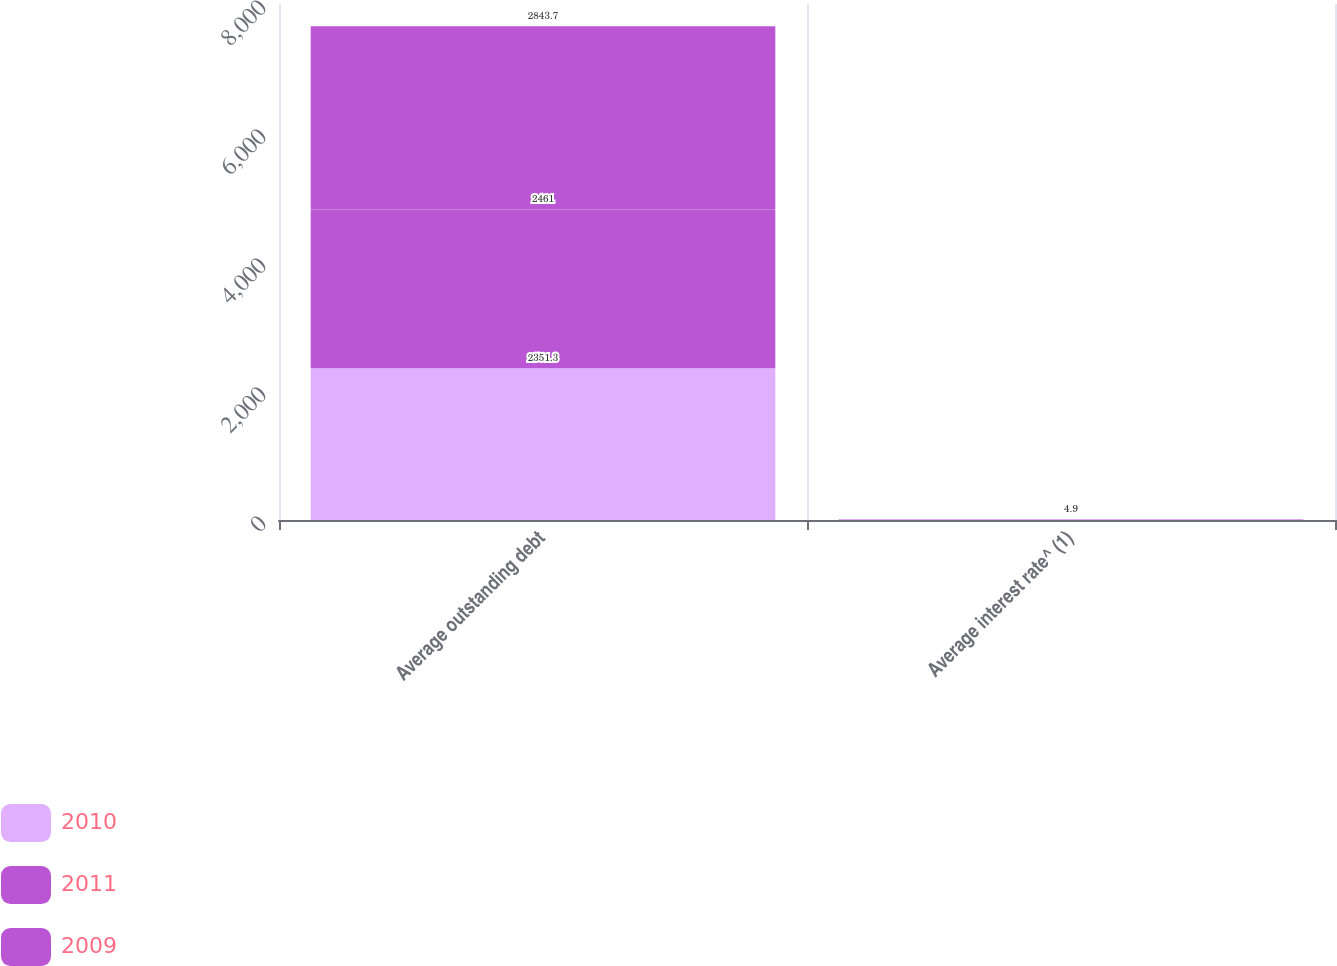<chart> <loc_0><loc_0><loc_500><loc_500><stacked_bar_chart><ecel><fcel>Average outstanding debt<fcel>Average interest rate^ (1)<nl><fcel>2010<fcel>2351.3<fcel>3.6<nl><fcel>2011<fcel>2461<fcel>4.8<nl><fcel>2009<fcel>2843.7<fcel>4.9<nl></chart> 